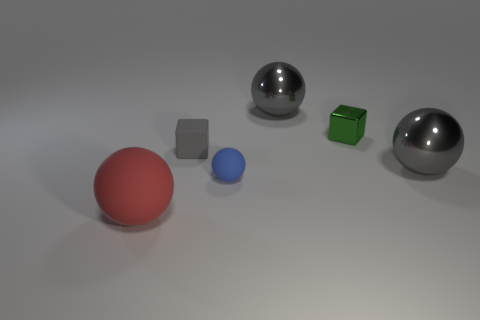Add 3 small gray objects. How many objects exist? 9 Subtract all red balls. Subtract all purple cylinders. How many balls are left? 3 Subtract all blocks. How many objects are left? 4 Subtract all big purple cubes. Subtract all tiny gray things. How many objects are left? 5 Add 1 large red rubber balls. How many large red rubber balls are left? 2 Add 2 big red balls. How many big red balls exist? 3 Subtract 0 green spheres. How many objects are left? 6 